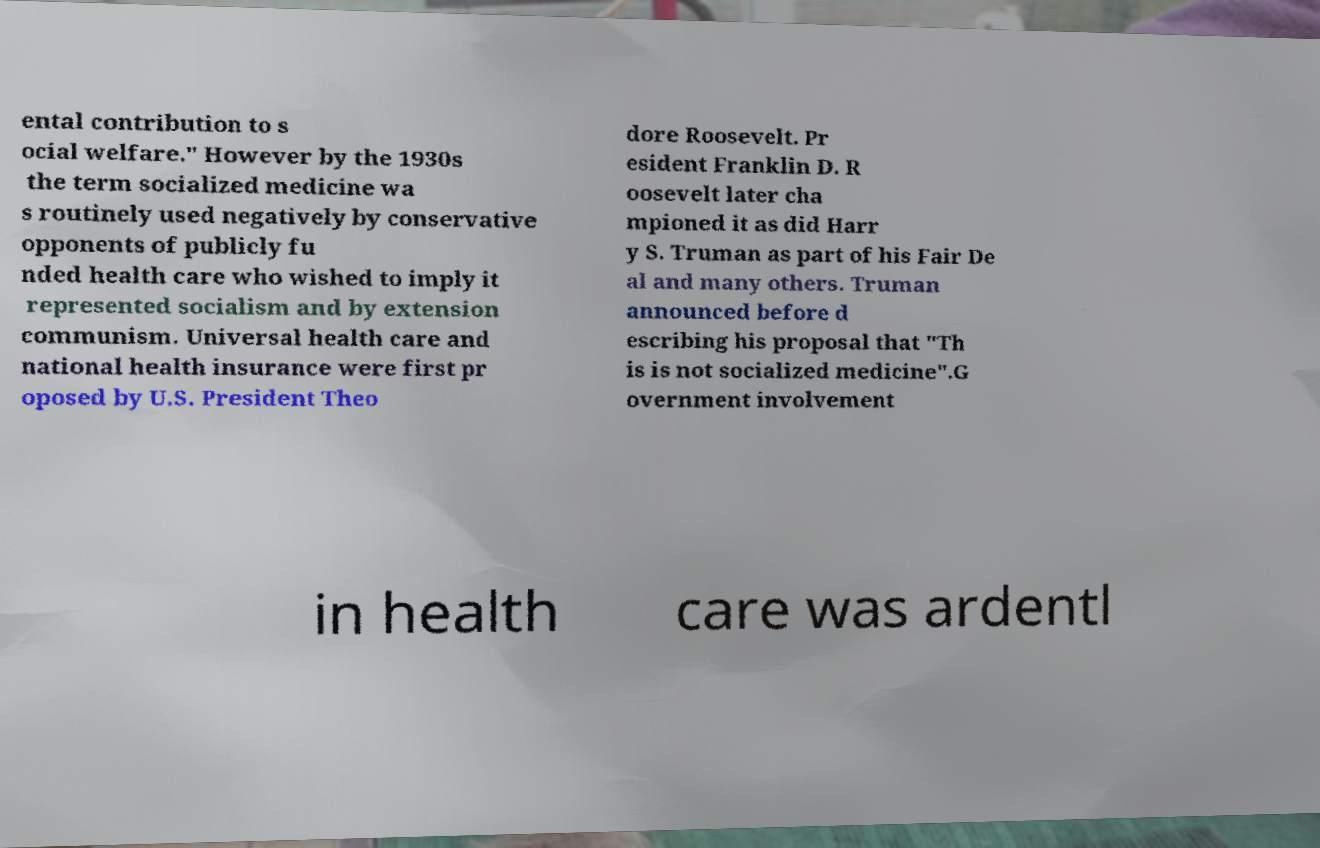Please read and relay the text visible in this image. What does it say? ental contribution to s ocial welfare." However by the 1930s the term socialized medicine wa s routinely used negatively by conservative opponents of publicly fu nded health care who wished to imply it represented socialism and by extension communism. Universal health care and national health insurance were first pr oposed by U.S. President Theo dore Roosevelt. Pr esident Franklin D. R oosevelt later cha mpioned it as did Harr y S. Truman as part of his Fair De al and many others. Truman announced before d escribing his proposal that "Th is is not socialized medicine".G overnment involvement in health care was ardentl 